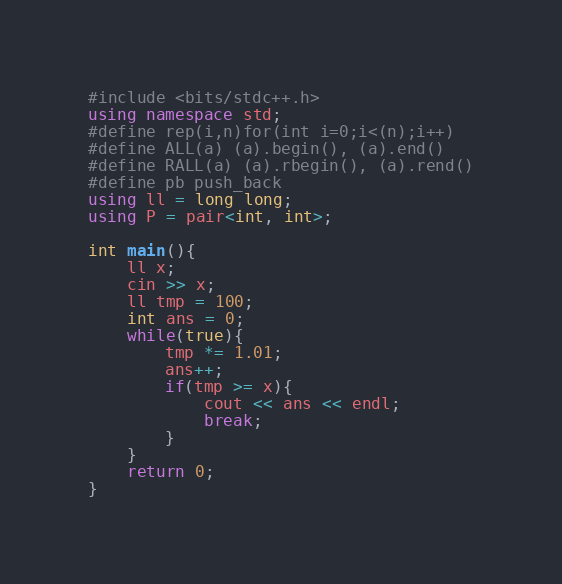<code> <loc_0><loc_0><loc_500><loc_500><_C++_>#include <bits/stdc++.h>
using namespace std;
#define rep(i,n)for(int i=0;i<(n);i++)
#define ALL(a) (a).begin(), (a).end()
#define RALL(a) (a).rbegin(), (a).rend()
#define pb push_back
using ll = long long;
using P = pair<int, int>;

int main(){
    ll x;
    cin >> x;
    ll tmp = 100;
    int ans = 0;
    while(true){
        tmp *= 1.01;
        ans++;
        if(tmp >= x){
            cout << ans << endl;
            break;
        }
    }
    return 0;
}</code> 